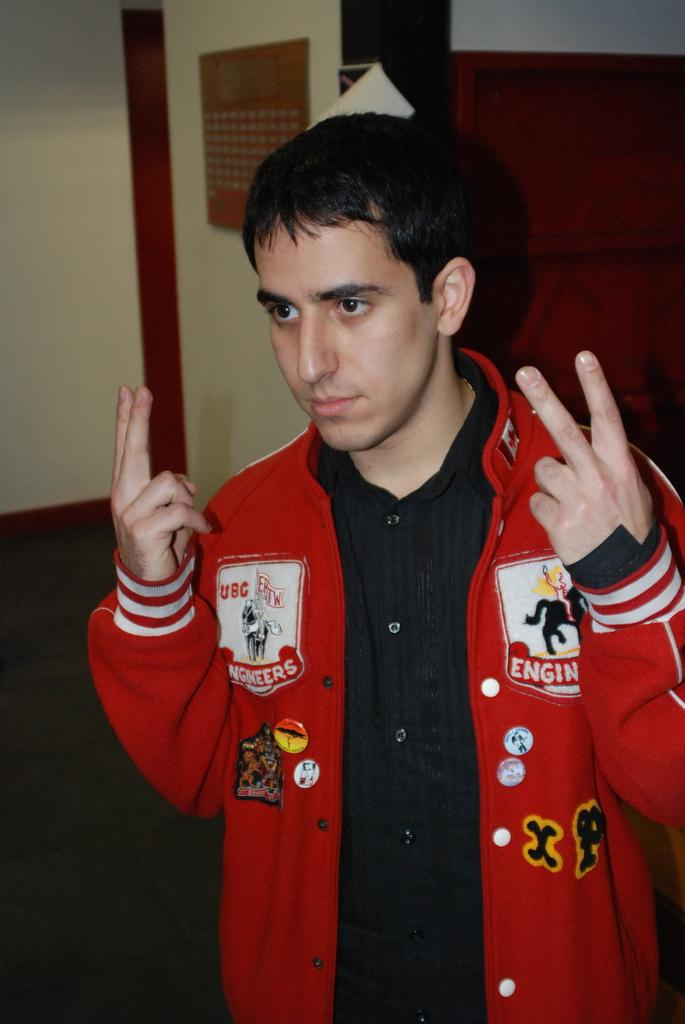Who is the main subject in the picture? There is a boy in the picture. What is the boy wearing? The boy is wearing a red jacket. What is the boy doing in the picture? The boy is standing in the front and posing for the camera. What can be seen in the background of the picture? There is a yellow wall in the background of the picture. What type of road is visible in the background of the picture? There is no road visible in the background of the picture; it features a yellow wall. What thought is the boy having while posing for the camera? We cannot determine the boy's thoughts from the image, as thoughts are not visible. 